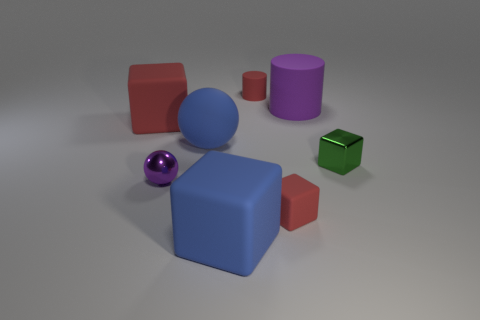Subtract all yellow cylinders. How many red blocks are left? 2 Subtract 1 blocks. How many blocks are left? 3 Subtract all tiny matte cubes. How many cubes are left? 3 Subtract all green blocks. How many blocks are left? 3 Add 2 small purple cylinders. How many objects exist? 10 Subtract all blue blocks. Subtract all gray spheres. How many blocks are left? 3 Subtract all cylinders. How many objects are left? 6 Subtract all big purple cylinders. Subtract all large red metal spheres. How many objects are left? 7 Add 2 red cubes. How many red cubes are left? 4 Add 6 purple cylinders. How many purple cylinders exist? 7 